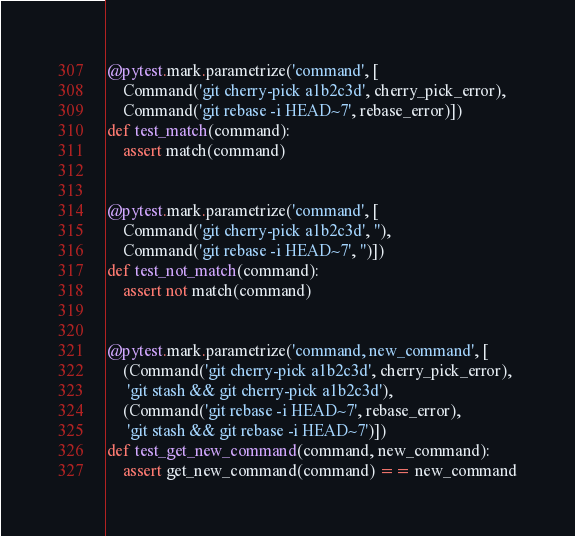Convert code to text. <code><loc_0><loc_0><loc_500><loc_500><_Python_>@pytest.mark.parametrize('command', [
    Command('git cherry-pick a1b2c3d', cherry_pick_error),
    Command('git rebase -i HEAD~7', rebase_error)])
def test_match(command):
    assert match(command)


@pytest.mark.parametrize('command', [
    Command('git cherry-pick a1b2c3d', ''),
    Command('git rebase -i HEAD~7', '')])
def test_not_match(command):
    assert not match(command)


@pytest.mark.parametrize('command, new_command', [
    (Command('git cherry-pick a1b2c3d', cherry_pick_error),
     'git stash && git cherry-pick a1b2c3d'),
    (Command('git rebase -i HEAD~7', rebase_error),
     'git stash && git rebase -i HEAD~7')])
def test_get_new_command(command, new_command):
    assert get_new_command(command) == new_command
</code> 